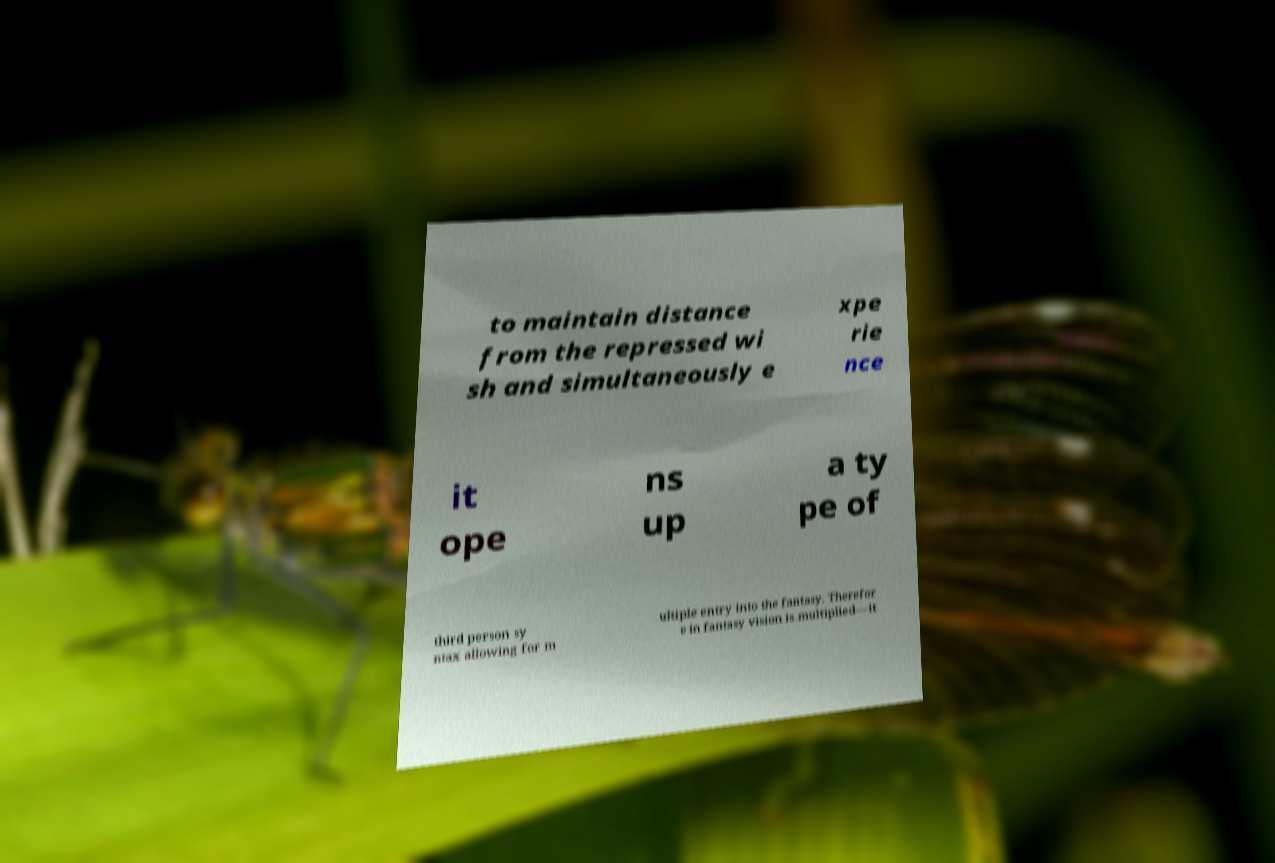I need the written content from this picture converted into text. Can you do that? to maintain distance from the repressed wi sh and simultaneously e xpe rie nce it ope ns up a ty pe of third person sy ntax allowing for m ultiple entry into the fantasy. Therefor e in fantasy vision is multiplied—it 